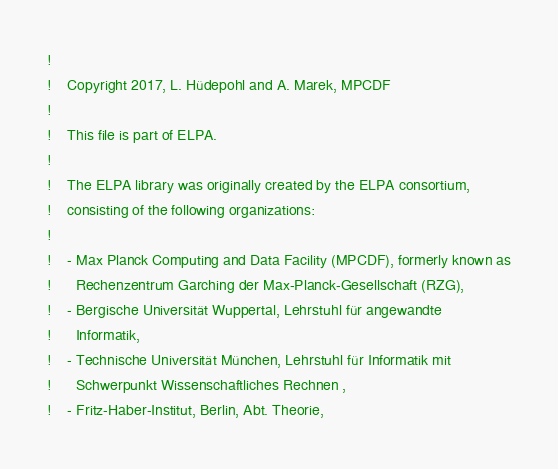<code> <loc_0><loc_0><loc_500><loc_500><_FORTRAN_>!
!    Copyright 2017, L. Hüdepohl and A. Marek, MPCDF
!
!    This file is part of ELPA.
!
!    The ELPA library was originally created by the ELPA consortium,
!    consisting of the following organizations:
!
!    - Max Planck Computing and Data Facility (MPCDF), formerly known as
!      Rechenzentrum Garching der Max-Planck-Gesellschaft (RZG),
!    - Bergische Universität Wuppertal, Lehrstuhl für angewandte
!      Informatik,
!    - Technische Universität München, Lehrstuhl für Informatik mit
!      Schwerpunkt Wissenschaftliches Rechnen ,
!    - Fritz-Haber-Institut, Berlin, Abt. Theorie,</code> 